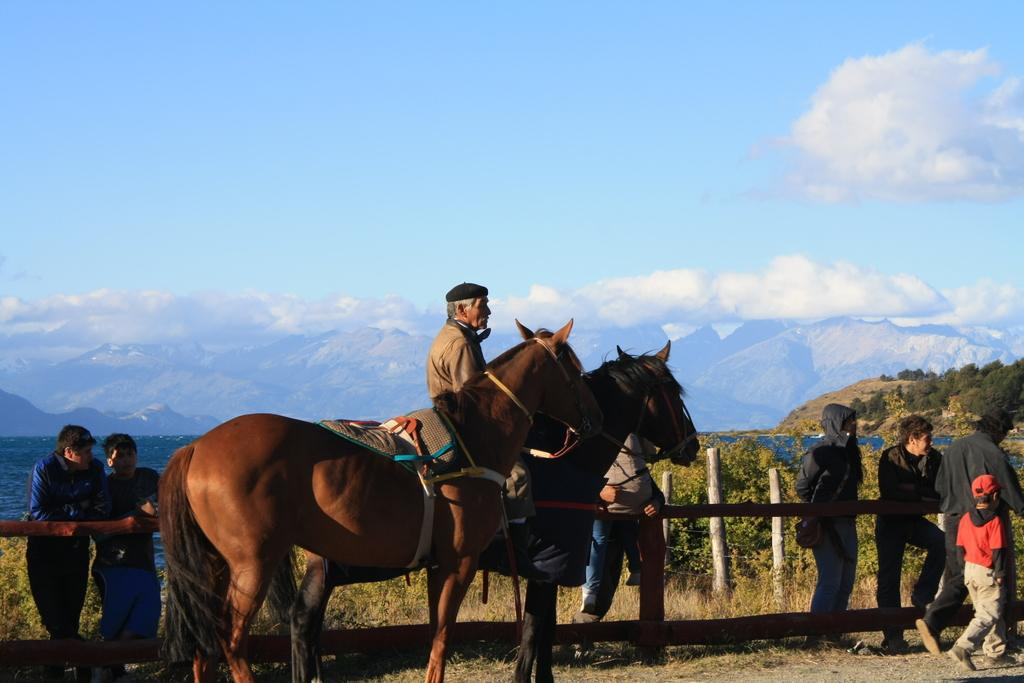What is the man in the image doing? The man is sitting on a horse. Are there any other horses in the image? Yes, there is another horse beside the man. What can be seen in the background of the image? There are beautiful mountains visible in the background. What is the condition of the sky in the image? The sky is visible in the image. How many women are folding clothes in the image? There are no women folding clothes in the image; it features a man sitting on a horse and other horses and people near a wooden fence. 